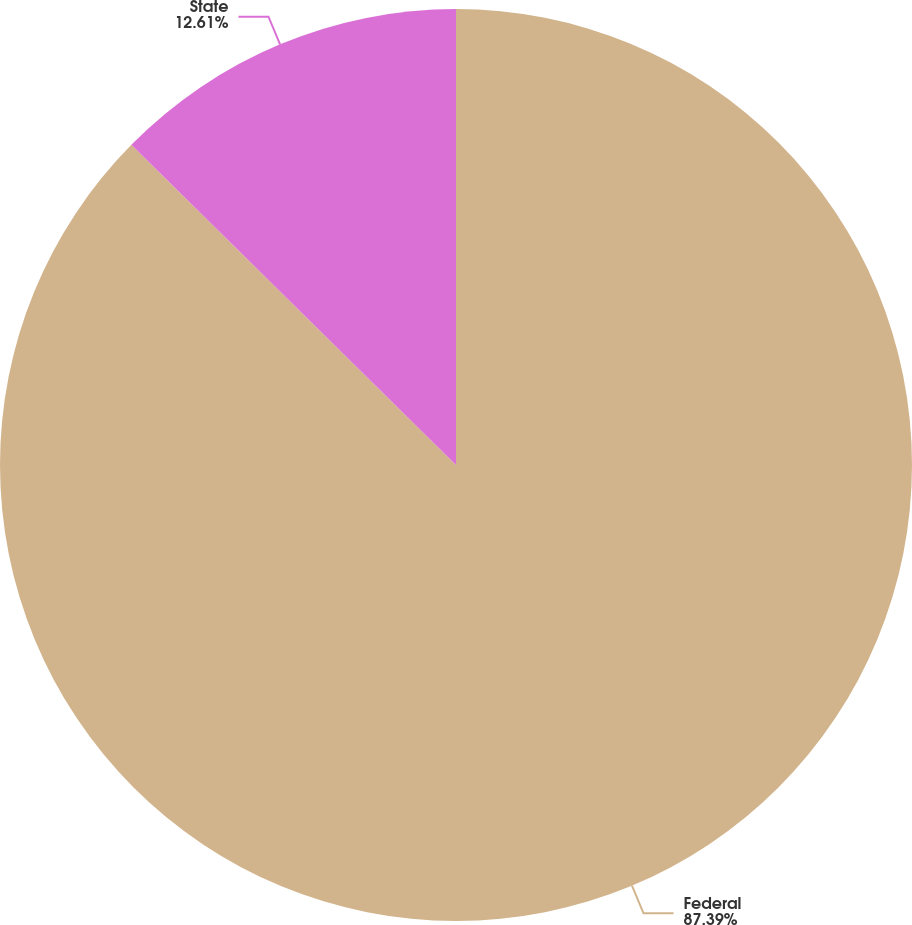<chart> <loc_0><loc_0><loc_500><loc_500><pie_chart><fcel>Federal<fcel>State<nl><fcel>87.39%<fcel>12.61%<nl></chart> 